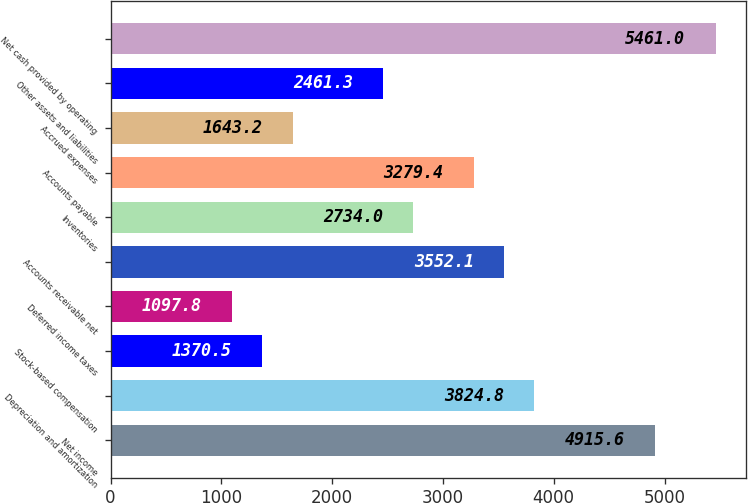Convert chart. <chart><loc_0><loc_0><loc_500><loc_500><bar_chart><fcel>Net income<fcel>Depreciation and amortization<fcel>Stock-based compensation<fcel>Deferred income taxes<fcel>Accounts receivable net<fcel>Inventories<fcel>Accounts payable<fcel>Accrued expenses<fcel>Other assets and liabilities<fcel>Net cash provided by operating<nl><fcel>4915.6<fcel>3824.8<fcel>1370.5<fcel>1097.8<fcel>3552.1<fcel>2734<fcel>3279.4<fcel>1643.2<fcel>2461.3<fcel>5461<nl></chart> 